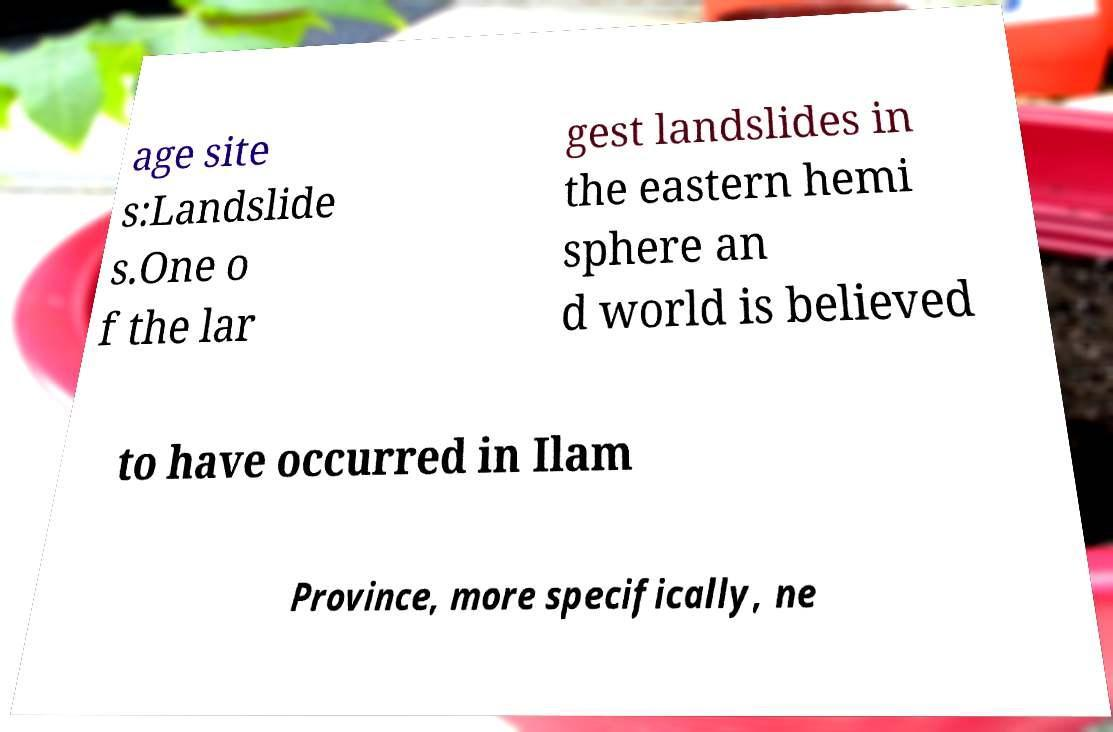Please read and relay the text visible in this image. What does it say? age site s:Landslide s.One o f the lar gest landslides in the eastern hemi sphere an d world is believed to have occurred in Ilam Province, more specifically, ne 